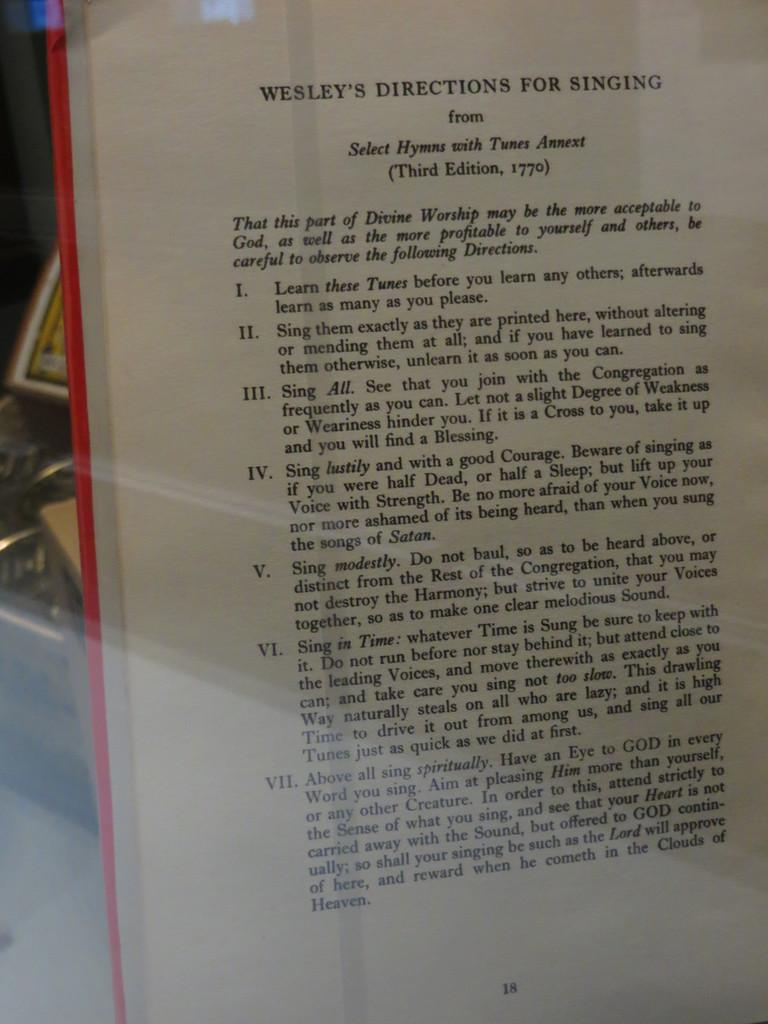Provide a one-sentence caption for the provided image. Wesley's Direction for singing third edition chapter book. 